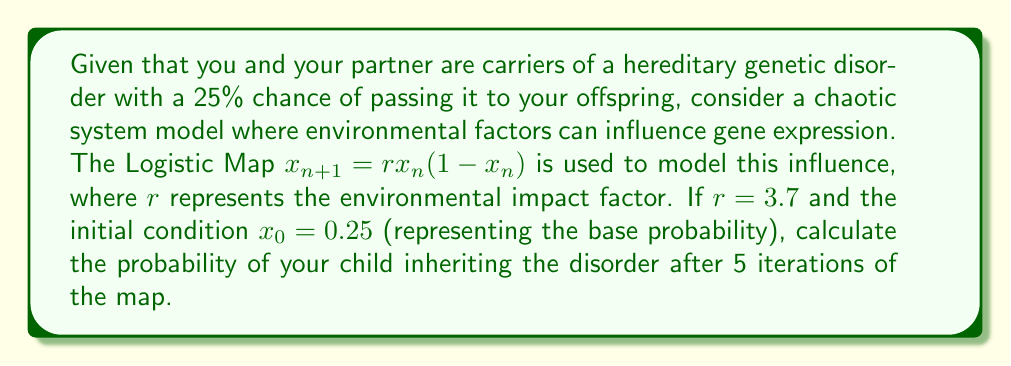Can you answer this question? To solve this problem, we need to iterate the Logistic Map equation 5 times, starting with the initial condition. Here's the step-by-step process:

1) The Logistic Map equation is given by:
   $$x_{n+1} = rx_n(1-x_n)$$
   where $r = 3.7$ and $x_0 = 0.25$

2) Let's calculate each iteration:

   Iteration 1:
   $$x_1 = 3.7 * 0.25 * (1-0.25) = 0.69375$$

   Iteration 2:
   $$x_2 = 3.7 * 0.69375 * (1-0.69375) \approx 0.7876$$

   Iteration 3:
   $$x_3 = 3.7 * 0.7876 * (1-0.7876) \approx 0.6207$$

   Iteration 4:
   $$x_4 = 3.7 * 0.6207 * (1-0.6207) \approx 0.8710$$

   Iteration 5:
   $$x_5 = 3.7 * 0.8710 * (1-0.8710) \approx 0.4151$$

3) The final value after 5 iterations is approximately 0.4151, which represents the new probability of inheriting the disorder under this chaotic system model.

4) To express this as a percentage, we multiply by 100:
   $$0.4151 * 100 \approx 41.51\%$$

Therefore, according to this chaotic system model, the probability of your child inheriting the disorder after considering environmental factors is approximately 41.51%.
Answer: 41.51% 